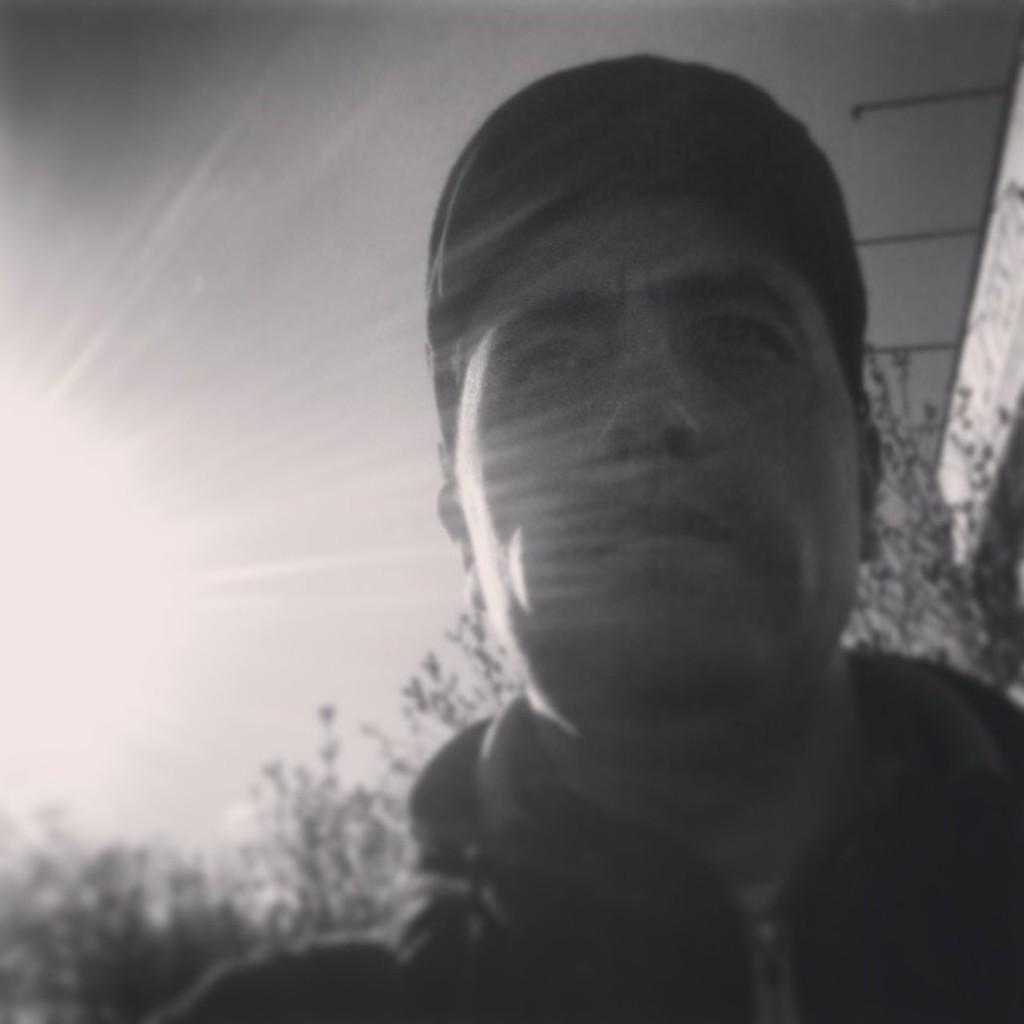Who or what is the main subject in the image? There is a person in the image. What can be seen in the background of the image? There are plants and the sky visible in the background of the image. What is the color scheme of the image? The image is in black and white. What verse is being recited by the person in the image? There is no indication in the image that the person is reciting a verse, so it cannot be determined from the picture. 